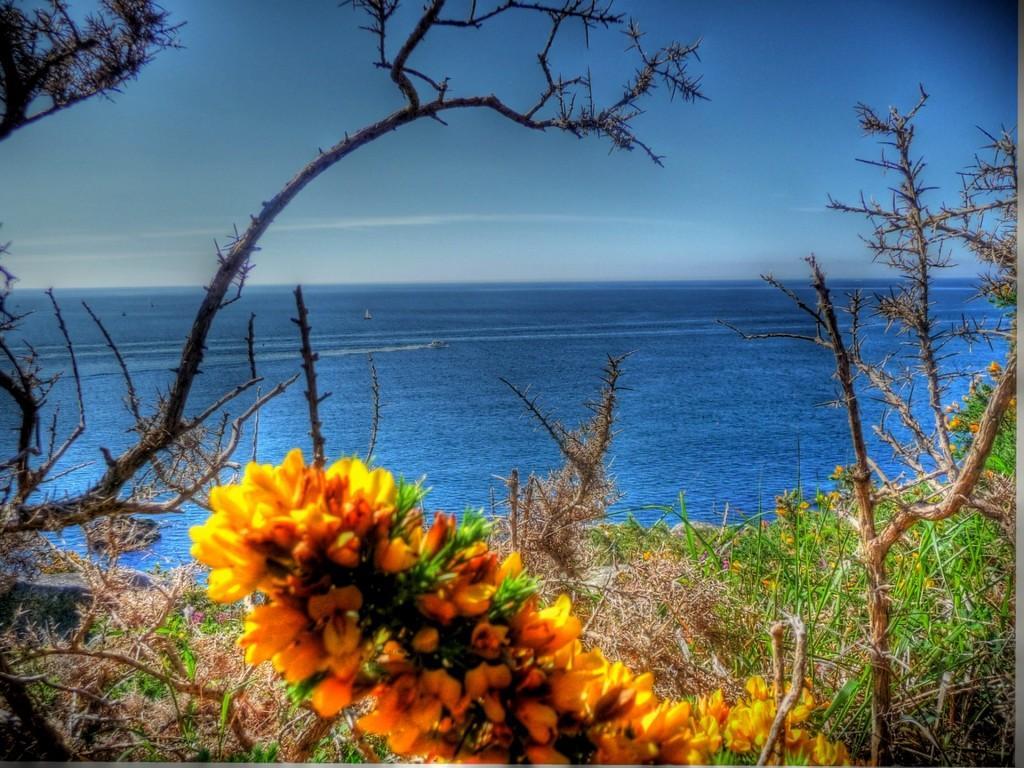Please provide a concise description of this image. In this picture we can see trees,flowers and we can see water,sky in the background. 